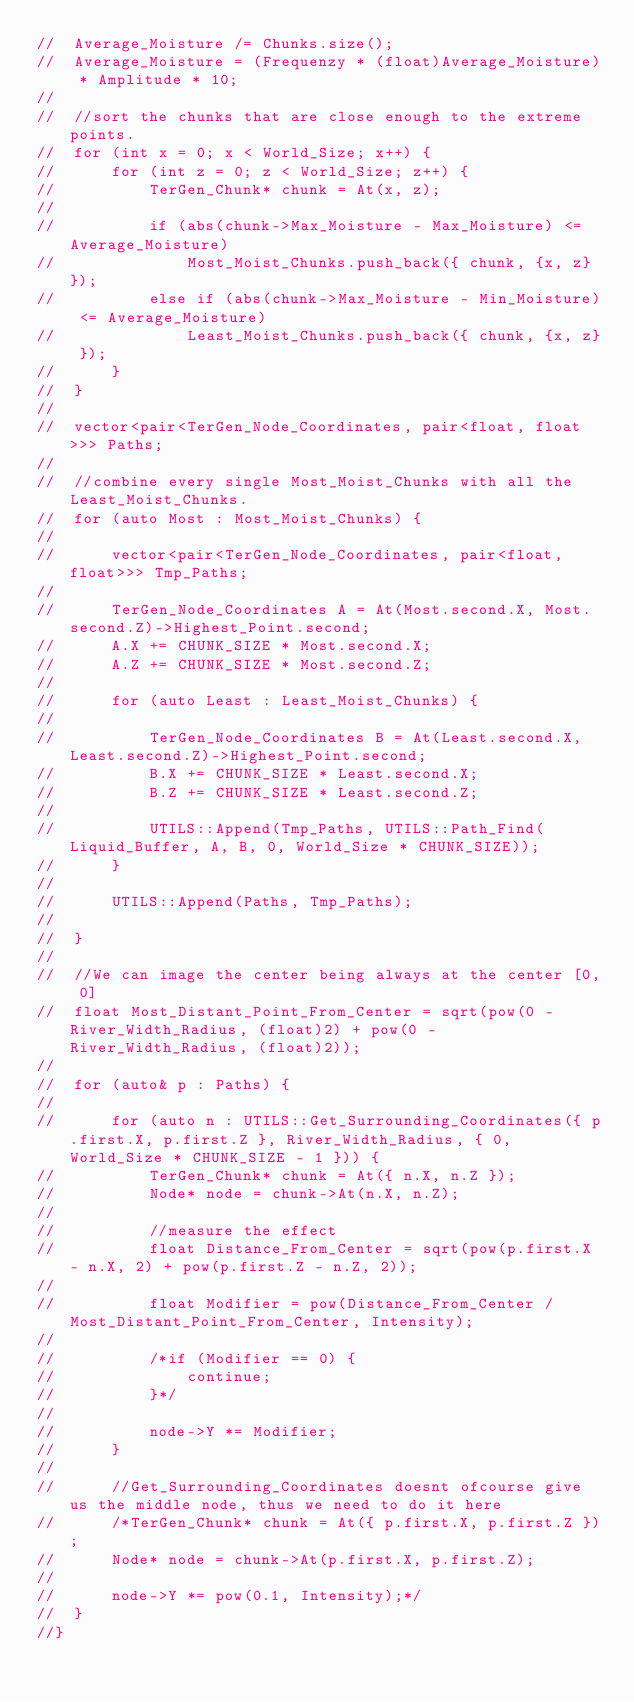Convert code to text. <code><loc_0><loc_0><loc_500><loc_500><_C++_>//	Average_Moisture /= Chunks.size();
//	Average_Moisture = (Frequenzy * (float)Average_Moisture) * Amplitude * 10;
//
//	//sort the chunks that are close enough to the extreme points.
//	for (int x = 0; x < World_Size; x++) {
//		for (int z = 0; z < World_Size; z++) {
//			TerGen_Chunk* chunk = At(x, z);
//
//			if (abs(chunk->Max_Moisture - Max_Moisture) <= Average_Moisture)
//				Most_Moist_Chunks.push_back({ chunk, {x, z} });
//			else if (abs(chunk->Max_Moisture - Min_Moisture) <= Average_Moisture)
//				Least_Moist_Chunks.push_back({ chunk, {x, z} });
//		}
//	}
//
//	vector<pair<TerGen_Node_Coordinates, pair<float, float>>> Paths;
//
//	//combine every single Most_Moist_Chunks with all the Least_Moist_Chunks.
//	for (auto Most : Most_Moist_Chunks) {
//
//		vector<pair<TerGen_Node_Coordinates, pair<float, float>>> Tmp_Paths;
//
//		TerGen_Node_Coordinates A = At(Most.second.X, Most.second.Z)->Highest_Point.second;
//		A.X += CHUNK_SIZE * Most.second.X;
//		A.Z += CHUNK_SIZE * Most.second.Z;
//
//		for (auto Least : Least_Moist_Chunks) {
//
//			TerGen_Node_Coordinates B = At(Least.second.X, Least.second.Z)->Highest_Point.second;
//			B.X += CHUNK_SIZE * Least.second.X;
//			B.Z += CHUNK_SIZE * Least.second.Z;
//
//			UTILS::Append(Tmp_Paths, UTILS::Path_Find(Liquid_Buffer, A, B, 0, World_Size * CHUNK_SIZE));
//		}
//
//		UTILS::Append(Paths, Tmp_Paths);
//
//	}
//
//	//We can image the center being always at the center [0, 0]
//	float Most_Distant_Point_From_Center = sqrt(pow(0 - River_Width_Radius, (float)2) + pow(0 - River_Width_Radius, (float)2));
//
//	for (auto& p : Paths) {
//
//		for (auto n : UTILS::Get_Surrounding_Coordinates({ p.first.X, p.first.Z }, River_Width_Radius, { 0, World_Size * CHUNK_SIZE - 1 })) {
//			TerGen_Chunk* chunk = At({ n.X, n.Z });
//			Node* node = chunk->At(n.X, n.Z);
//
//			//measure the effect
//			float Distance_From_Center = sqrt(pow(p.first.X - n.X, 2) + pow(p.first.Z - n.Z, 2));
//
//			float Modifier = pow(Distance_From_Center / Most_Distant_Point_From_Center, Intensity);
//
//			/*if (Modifier == 0) {
//				continue;
//			}*/
//
//			node->Y *= Modifier;
//		}
//
//		//Get_Surrounding_Coordinates doesnt ofcourse give us the middle node, thus we need to do it here
//		/*TerGen_Chunk* chunk = At({ p.first.X, p.first.Z });
//		Node* node = chunk->At(p.first.X, p.first.Z);
//
//		node->Y *= pow(0.1, Intensity);*/
//	}
//}

</code> 